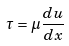Convert formula to latex. <formula><loc_0><loc_0><loc_500><loc_500>\tau = \mu \frac { d u } { d x }</formula> 